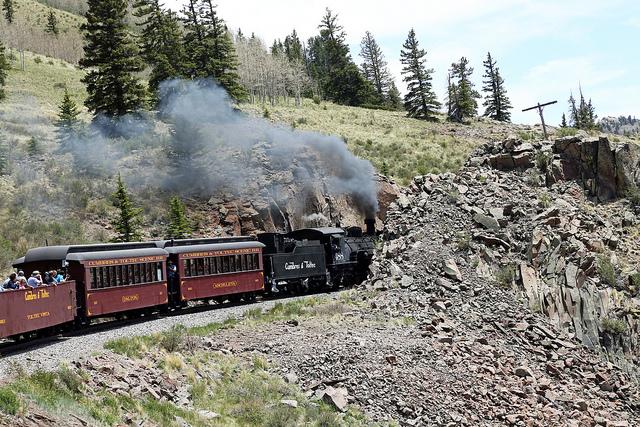What color is the front car of the train?
Write a very short answer. Black. Is this train in a tunnel?
Quick response, please. Yes. What type of train engine is this?
Keep it brief. Steam. Is there pollution?
Answer briefly. Yes. Is this a desert scene?
Keep it brief. No. 